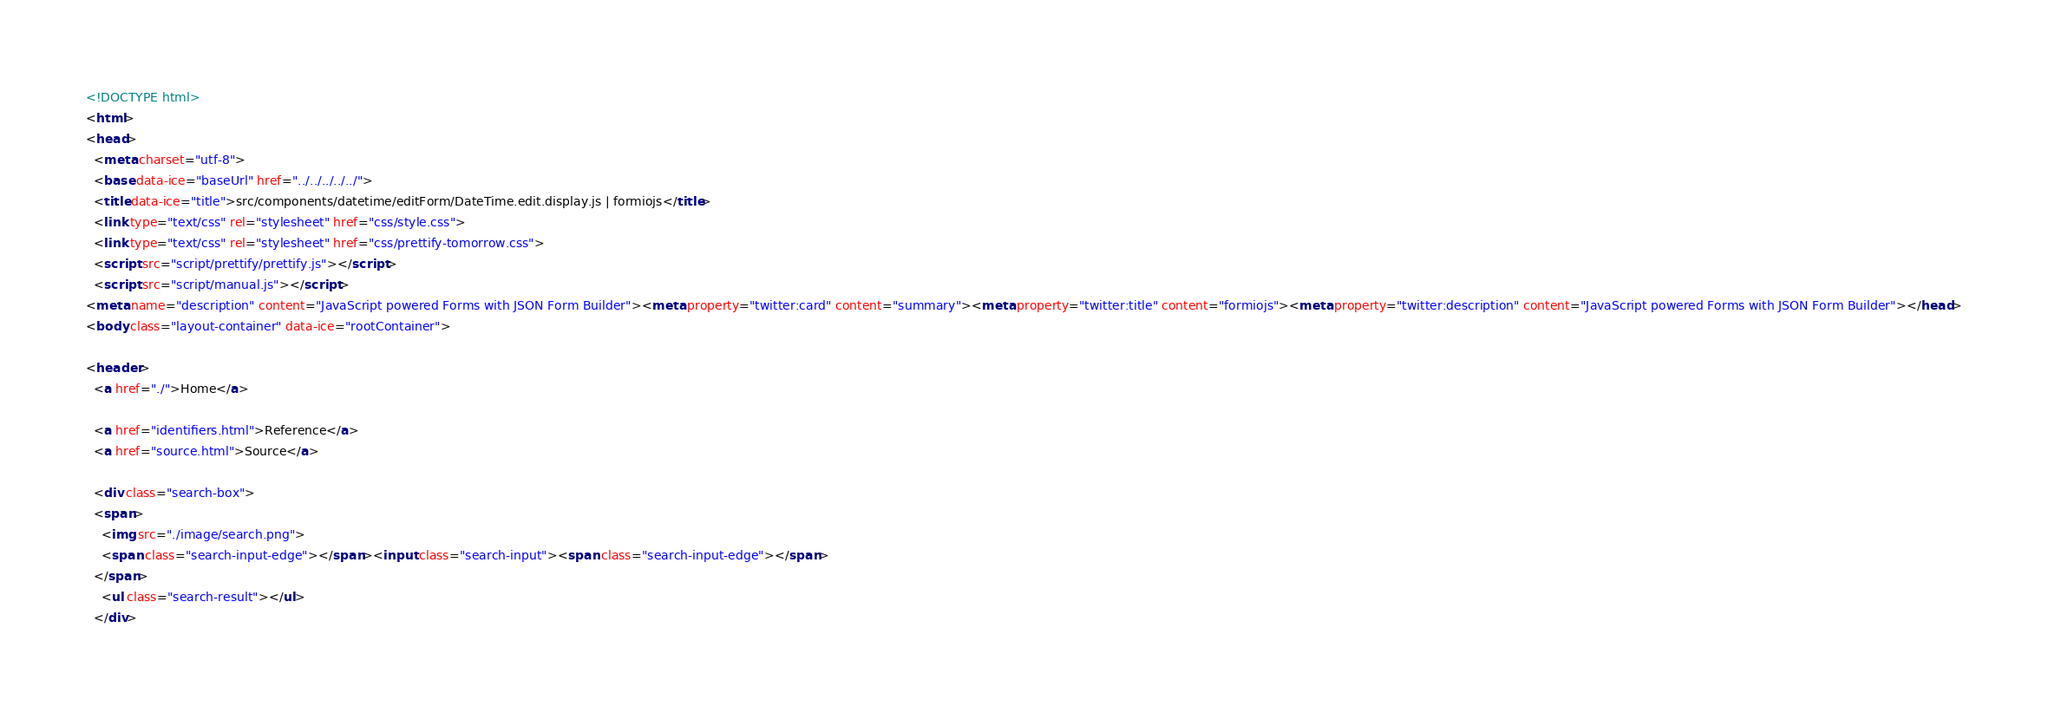Convert code to text. <code><loc_0><loc_0><loc_500><loc_500><_HTML_><!DOCTYPE html>
<html>
<head>
  <meta charset="utf-8">
  <base data-ice="baseUrl" href="../../../../../">
  <title data-ice="title">src/components/datetime/editForm/DateTime.edit.display.js | formiojs</title>
  <link type="text/css" rel="stylesheet" href="css/style.css">
  <link type="text/css" rel="stylesheet" href="css/prettify-tomorrow.css">
  <script src="script/prettify/prettify.js"></script>
  <script src="script/manual.js"></script>
<meta name="description" content="JavaScript powered Forms with JSON Form Builder"><meta property="twitter:card" content="summary"><meta property="twitter:title" content="formiojs"><meta property="twitter:description" content="JavaScript powered Forms with JSON Form Builder"></head>
<body class="layout-container" data-ice="rootContainer">

<header>
  <a href="./">Home</a>
  
  <a href="identifiers.html">Reference</a>
  <a href="source.html">Source</a>
  
  <div class="search-box">
  <span>
    <img src="./image/search.png">
    <span class="search-input-edge"></span><input class="search-input"><span class="search-input-edge"></span>
  </span>
    <ul class="search-result"></ul>
  </div></code> 